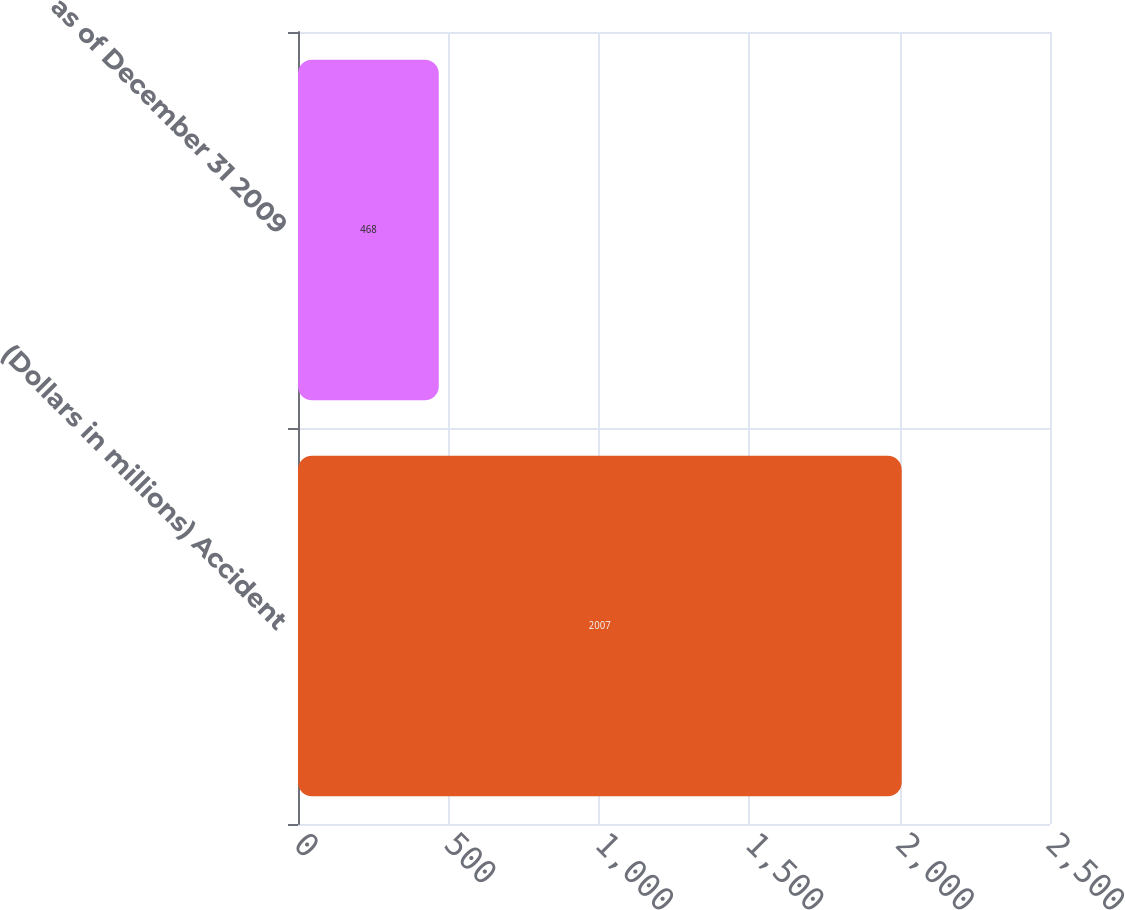<chart> <loc_0><loc_0><loc_500><loc_500><bar_chart><fcel>(Dollars in millions) Accident<fcel>as of December 31 2009<nl><fcel>2007<fcel>468<nl></chart> 